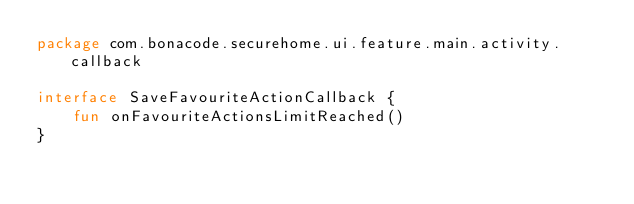<code> <loc_0><loc_0><loc_500><loc_500><_Kotlin_>package com.bonacode.securehome.ui.feature.main.activity.callback

interface SaveFavouriteActionCallback {
    fun onFavouriteActionsLimitReached()
}
</code> 